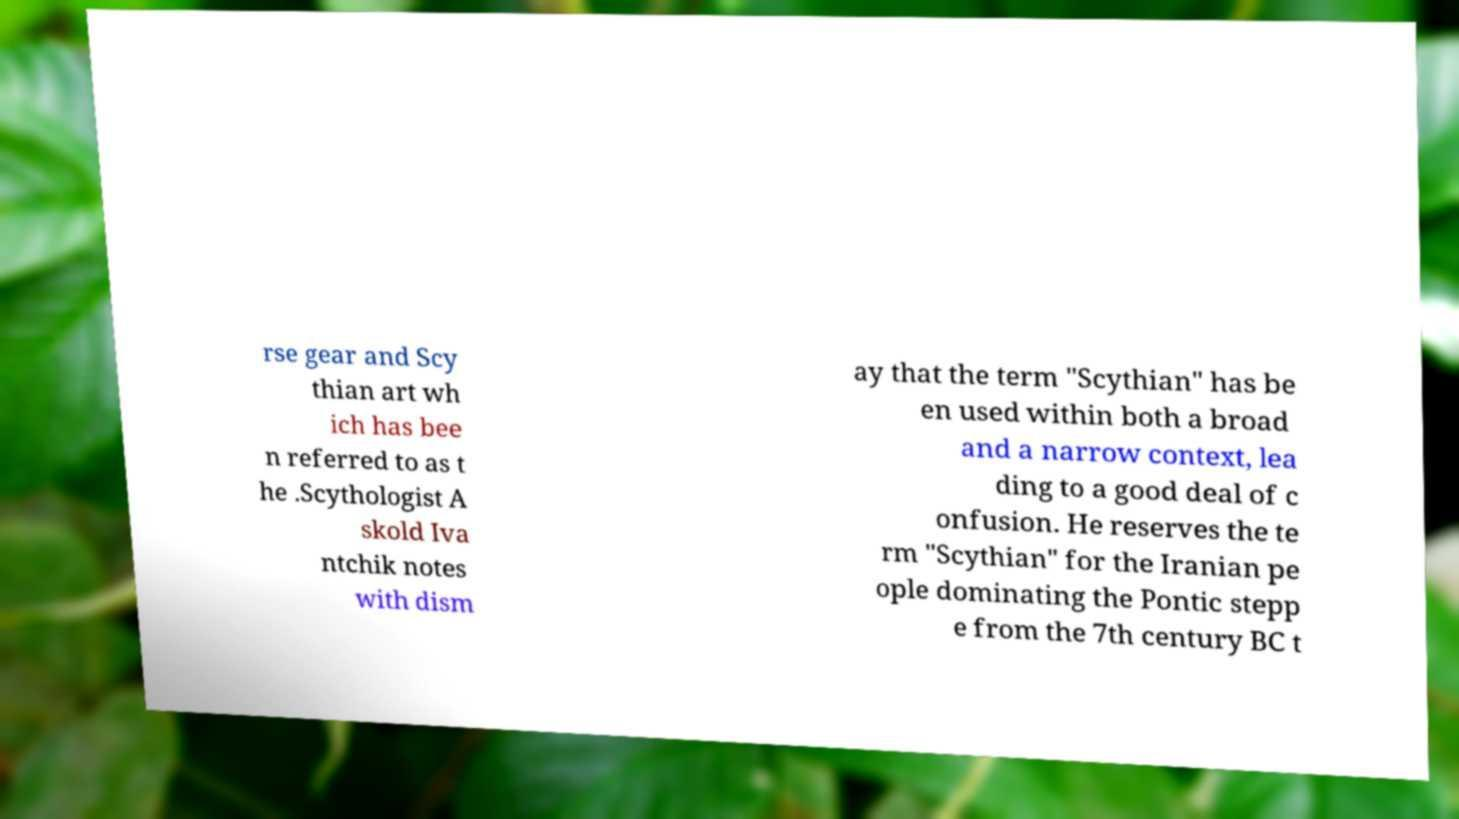Could you extract and type out the text from this image? rse gear and Scy thian art wh ich has bee n referred to as t he .Scythologist A skold Iva ntchik notes with dism ay that the term "Scythian" has be en used within both a broad and a narrow context, lea ding to a good deal of c onfusion. He reserves the te rm "Scythian" for the Iranian pe ople dominating the Pontic stepp e from the 7th century BC t 